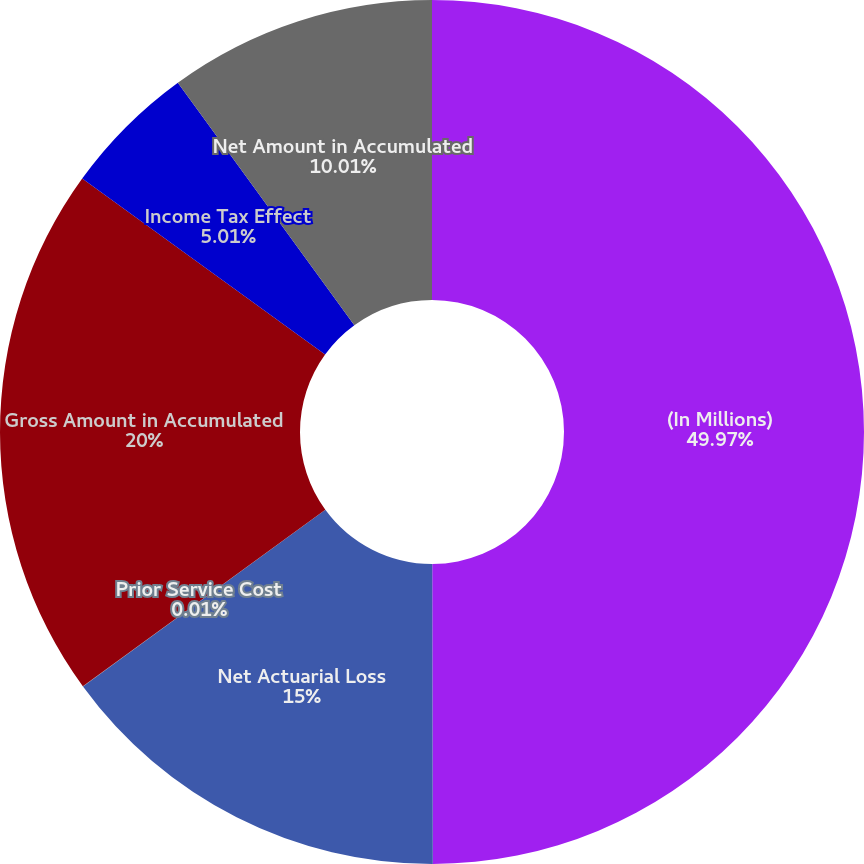Convert chart to OTSL. <chart><loc_0><loc_0><loc_500><loc_500><pie_chart><fcel>(In Millions)<fcel>Net Actuarial Loss<fcel>Prior Service Cost<fcel>Gross Amount in Accumulated<fcel>Income Tax Effect<fcel>Net Amount in Accumulated<nl><fcel>49.97%<fcel>15.0%<fcel>0.01%<fcel>20.0%<fcel>5.01%<fcel>10.01%<nl></chart> 